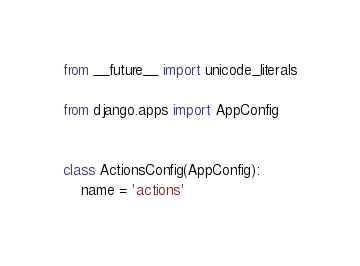<code> <loc_0><loc_0><loc_500><loc_500><_Python_>from __future__ import unicode_literals

from django.apps import AppConfig


class ActionsConfig(AppConfig):
    name = 'actions'
</code> 